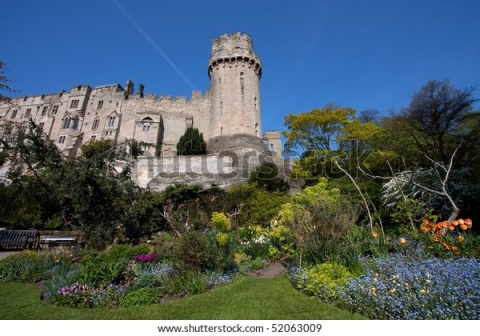What kind of events might be held in this castle and its garden? This picturesque castle and its vibrant garden would be an ideal location for a variety of events. The grand halls of the castle could host elegant balls and banquets, where guests dressed in their finest attire dance under the glow of chandeliers. Historic re-enactments and medieval fairs might take place within the castle grounds, offering visitors a glimpse into the past with jousting tournaments, artisanal crafts, and traditional feasts.

The garden, with its riot of colors and serene ambiance, would be perfect for more intimate gatherings. Garden parties, high teas, and romantic weddings could be beautifully arranged amidst the blooming flowers and lush greenery. The bench in the foreground provides a perfect spot for quiet contemplation or a cozy chat. Seasonal events such as spring flower festivals or autumn harvest celebrations could also be enjoyed in this charming outdoor setting.  Imagine the castle is transferred to a futuristic setting. How would it be utilized? In a futuristic setting, this historic castle could be transformed into a cutting-edge research facility or a luxury retreat. With advanced technology seamlessly integrated into its medieval architecture, it could serve as a unique juxtaposition of past and future. The castle's robust structure would house state-of-the-art laboratories and observatories for scientific research, ranging from astrophysics to biotechnology.

Alternatively, the castle could be converted into an exclusive resort, catering to elite guests seeking an immersive experience in a blend of history and futuristic comfort. The gardens would feature automated maintenance systems and augmented reality displays showcasing the castle's rich history. The clear blue sky could be enhanced with celestial projections or even shielded domes controlling the environment, ensuring perfect weather conditions year-round. 